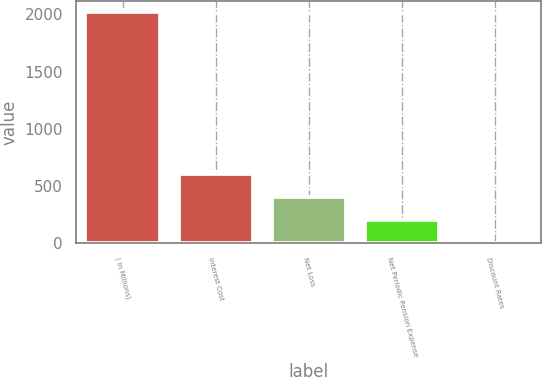Convert chart to OTSL. <chart><loc_0><loc_0><loc_500><loc_500><bar_chart><fcel>( In Millions)<fcel>Interest Cost<fcel>Net Loss<fcel>Net Periodic Pension Expense<fcel>Discount Rates<nl><fcel>2017<fcel>608.21<fcel>406.96<fcel>205.71<fcel>4.46<nl></chart> 